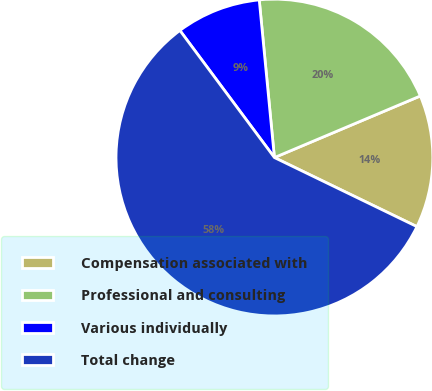Convert chart to OTSL. <chart><loc_0><loc_0><loc_500><loc_500><pie_chart><fcel>Compensation associated with<fcel>Professional and consulting<fcel>Various individually<fcel>Total change<nl><fcel>13.54%<fcel>20.17%<fcel>8.65%<fcel>57.64%<nl></chart> 